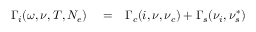Convert formula to latex. <formula><loc_0><loc_0><loc_500><loc_500>\begin{array} { r l r } { \Gamma _ { i } ( \omega , \nu , T , N _ { e } ) } & = } & { \Gamma _ { c } ( i , \nu , \nu _ { c } ) + \Gamma _ { s } ( \nu _ { i } , \nu _ { s } ^ { * } ) } \end{array}</formula> 